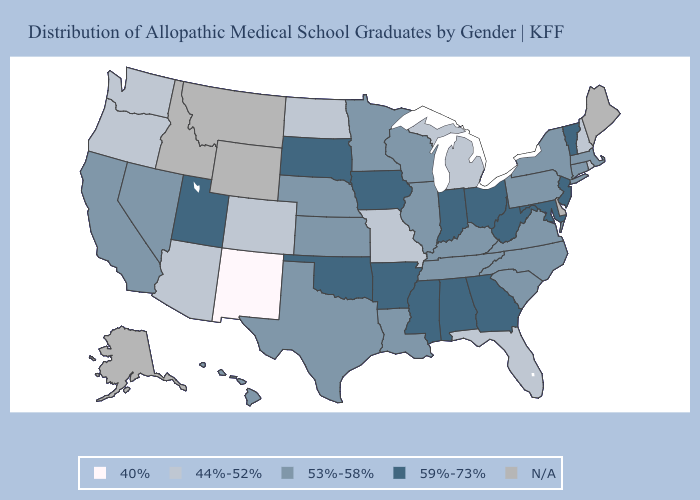What is the lowest value in the South?
Quick response, please. 44%-52%. Name the states that have a value in the range N/A?
Be succinct. Alaska, Delaware, Idaho, Maine, Montana, Wyoming. Name the states that have a value in the range 44%-52%?
Be succinct. Arizona, Colorado, Florida, Michigan, Missouri, New Hampshire, North Dakota, Oregon, Rhode Island, Washington. Among the states that border New Hampshire , does Massachusetts have the lowest value?
Give a very brief answer. Yes. What is the highest value in states that border Wisconsin?
Be succinct. 59%-73%. Does Florida have the lowest value in the South?
Be succinct. Yes. Which states have the highest value in the USA?
Write a very short answer. Alabama, Arkansas, Georgia, Indiana, Iowa, Maryland, Mississippi, New Jersey, Ohio, Oklahoma, South Dakota, Utah, Vermont, West Virginia. Does New Mexico have the lowest value in the USA?
Write a very short answer. Yes. Name the states that have a value in the range N/A?
Be succinct. Alaska, Delaware, Idaho, Maine, Montana, Wyoming. How many symbols are there in the legend?
Write a very short answer. 5. What is the lowest value in the USA?
Answer briefly. 40%. Does New Hampshire have the lowest value in the Northeast?
Quick response, please. Yes. What is the value of Missouri?
Quick response, please. 44%-52%. Which states have the lowest value in the USA?
Concise answer only. New Mexico. 